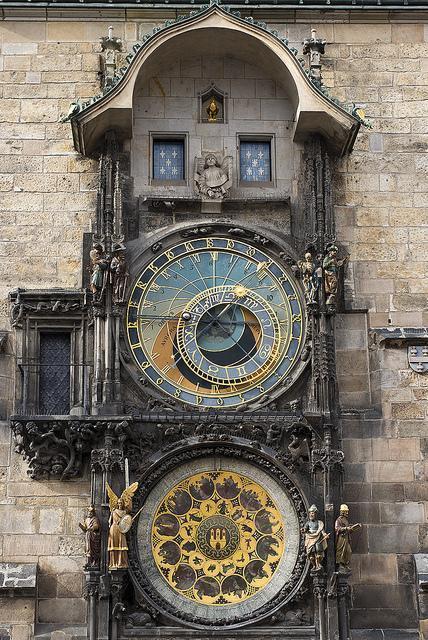How many windows?
Give a very brief answer. 3. How many clocks can be seen?
Give a very brief answer. 2. How many cups are in this picture?
Give a very brief answer. 0. 